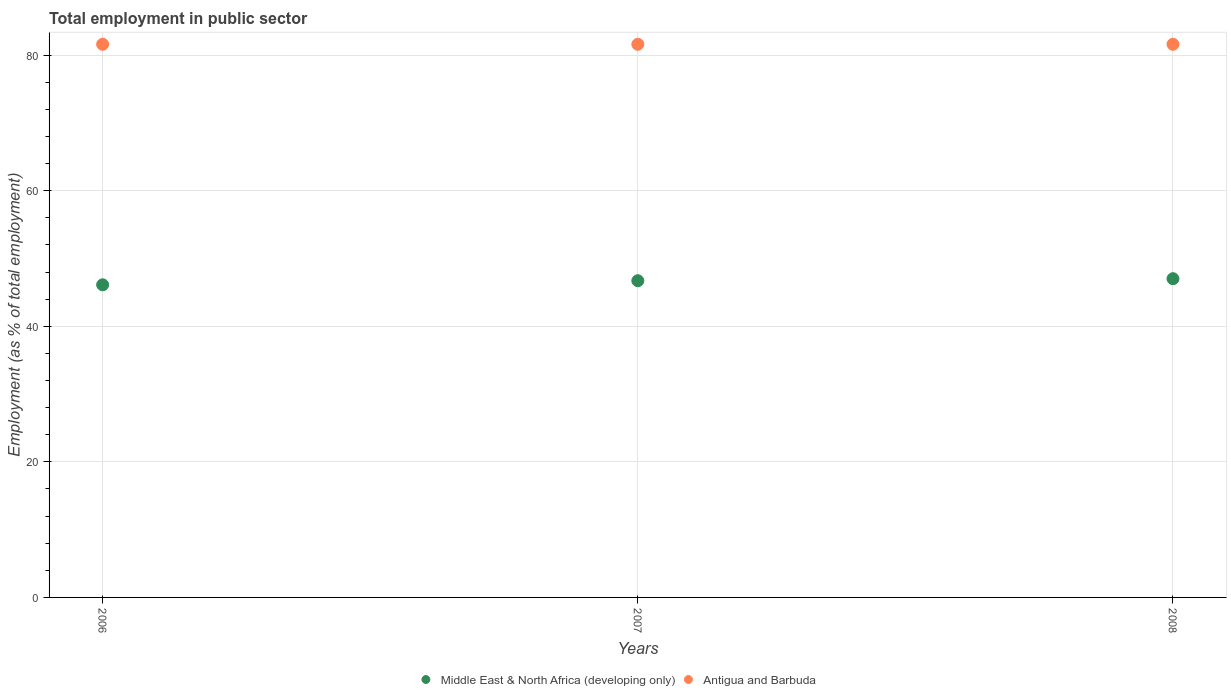Is the number of dotlines equal to the number of legend labels?
Ensure brevity in your answer.  Yes. What is the employment in public sector in Antigua and Barbuda in 2007?
Keep it short and to the point. 81.6. Across all years, what is the maximum employment in public sector in Middle East & North Africa (developing only)?
Offer a terse response. 47.02. Across all years, what is the minimum employment in public sector in Middle East & North Africa (developing only)?
Offer a very short reply. 46.12. What is the total employment in public sector in Middle East & North Africa (developing only) in the graph?
Provide a succinct answer. 139.86. What is the difference between the employment in public sector in Middle East & North Africa (developing only) in 2007 and that in 2008?
Provide a short and direct response. -0.3. What is the difference between the employment in public sector in Middle East & North Africa (developing only) in 2006 and the employment in public sector in Antigua and Barbuda in 2007?
Provide a short and direct response. -35.48. What is the average employment in public sector in Antigua and Barbuda per year?
Your answer should be compact. 81.6. In the year 2006, what is the difference between the employment in public sector in Antigua and Barbuda and employment in public sector in Middle East & North Africa (developing only)?
Your answer should be very brief. 35.48. What is the ratio of the employment in public sector in Antigua and Barbuda in 2007 to that in 2008?
Provide a short and direct response. 1. Is the difference between the employment in public sector in Antigua and Barbuda in 2006 and 2008 greater than the difference between the employment in public sector in Middle East & North Africa (developing only) in 2006 and 2008?
Provide a succinct answer. Yes. What is the difference between the highest and the second highest employment in public sector in Middle East & North Africa (developing only)?
Your answer should be very brief. 0.3. What is the difference between the highest and the lowest employment in public sector in Middle East & North Africa (developing only)?
Ensure brevity in your answer.  0.9. In how many years, is the employment in public sector in Middle East & North Africa (developing only) greater than the average employment in public sector in Middle East & North Africa (developing only) taken over all years?
Your answer should be compact. 2. Is the sum of the employment in public sector in Antigua and Barbuda in 2007 and 2008 greater than the maximum employment in public sector in Middle East & North Africa (developing only) across all years?
Provide a succinct answer. Yes. Is the employment in public sector in Antigua and Barbuda strictly greater than the employment in public sector in Middle East & North Africa (developing only) over the years?
Your answer should be compact. Yes. Is the employment in public sector in Antigua and Barbuda strictly less than the employment in public sector in Middle East & North Africa (developing only) over the years?
Offer a terse response. No. How many years are there in the graph?
Your answer should be very brief. 3. Are the values on the major ticks of Y-axis written in scientific E-notation?
Make the answer very short. No. Does the graph contain any zero values?
Offer a terse response. No. Where does the legend appear in the graph?
Your answer should be very brief. Bottom center. How are the legend labels stacked?
Make the answer very short. Horizontal. What is the title of the graph?
Provide a short and direct response. Total employment in public sector. Does "Uzbekistan" appear as one of the legend labels in the graph?
Offer a terse response. No. What is the label or title of the Y-axis?
Your response must be concise. Employment (as % of total employment). What is the Employment (as % of total employment) in Middle East & North Africa (developing only) in 2006?
Give a very brief answer. 46.12. What is the Employment (as % of total employment) of Antigua and Barbuda in 2006?
Offer a terse response. 81.6. What is the Employment (as % of total employment) in Middle East & North Africa (developing only) in 2007?
Give a very brief answer. 46.72. What is the Employment (as % of total employment) of Antigua and Barbuda in 2007?
Offer a very short reply. 81.6. What is the Employment (as % of total employment) in Middle East & North Africa (developing only) in 2008?
Your answer should be compact. 47.02. What is the Employment (as % of total employment) in Antigua and Barbuda in 2008?
Your answer should be very brief. 81.6. Across all years, what is the maximum Employment (as % of total employment) in Middle East & North Africa (developing only)?
Provide a succinct answer. 47.02. Across all years, what is the maximum Employment (as % of total employment) of Antigua and Barbuda?
Offer a very short reply. 81.6. Across all years, what is the minimum Employment (as % of total employment) of Middle East & North Africa (developing only)?
Your answer should be compact. 46.12. Across all years, what is the minimum Employment (as % of total employment) in Antigua and Barbuda?
Your response must be concise. 81.6. What is the total Employment (as % of total employment) in Middle East & North Africa (developing only) in the graph?
Your answer should be compact. 139.86. What is the total Employment (as % of total employment) in Antigua and Barbuda in the graph?
Offer a terse response. 244.8. What is the difference between the Employment (as % of total employment) in Middle East & North Africa (developing only) in 2006 and that in 2007?
Ensure brevity in your answer.  -0.61. What is the difference between the Employment (as % of total employment) in Antigua and Barbuda in 2006 and that in 2007?
Your response must be concise. 0. What is the difference between the Employment (as % of total employment) of Middle East & North Africa (developing only) in 2006 and that in 2008?
Offer a very short reply. -0.9. What is the difference between the Employment (as % of total employment) of Middle East & North Africa (developing only) in 2007 and that in 2008?
Your answer should be very brief. -0.3. What is the difference between the Employment (as % of total employment) of Middle East & North Africa (developing only) in 2006 and the Employment (as % of total employment) of Antigua and Barbuda in 2007?
Your response must be concise. -35.48. What is the difference between the Employment (as % of total employment) in Middle East & North Africa (developing only) in 2006 and the Employment (as % of total employment) in Antigua and Barbuda in 2008?
Your answer should be compact. -35.48. What is the difference between the Employment (as % of total employment) of Middle East & North Africa (developing only) in 2007 and the Employment (as % of total employment) of Antigua and Barbuda in 2008?
Make the answer very short. -34.88. What is the average Employment (as % of total employment) in Middle East & North Africa (developing only) per year?
Offer a very short reply. 46.62. What is the average Employment (as % of total employment) in Antigua and Barbuda per year?
Offer a terse response. 81.6. In the year 2006, what is the difference between the Employment (as % of total employment) in Middle East & North Africa (developing only) and Employment (as % of total employment) in Antigua and Barbuda?
Offer a very short reply. -35.48. In the year 2007, what is the difference between the Employment (as % of total employment) in Middle East & North Africa (developing only) and Employment (as % of total employment) in Antigua and Barbuda?
Provide a succinct answer. -34.88. In the year 2008, what is the difference between the Employment (as % of total employment) of Middle East & North Africa (developing only) and Employment (as % of total employment) of Antigua and Barbuda?
Your answer should be very brief. -34.58. What is the ratio of the Employment (as % of total employment) of Antigua and Barbuda in 2006 to that in 2007?
Your response must be concise. 1. What is the ratio of the Employment (as % of total employment) of Middle East & North Africa (developing only) in 2006 to that in 2008?
Give a very brief answer. 0.98. What is the ratio of the Employment (as % of total employment) in Antigua and Barbuda in 2007 to that in 2008?
Provide a short and direct response. 1. What is the difference between the highest and the second highest Employment (as % of total employment) of Middle East & North Africa (developing only)?
Your response must be concise. 0.3. What is the difference between the highest and the second highest Employment (as % of total employment) of Antigua and Barbuda?
Offer a very short reply. 0. What is the difference between the highest and the lowest Employment (as % of total employment) in Middle East & North Africa (developing only)?
Provide a short and direct response. 0.9. 